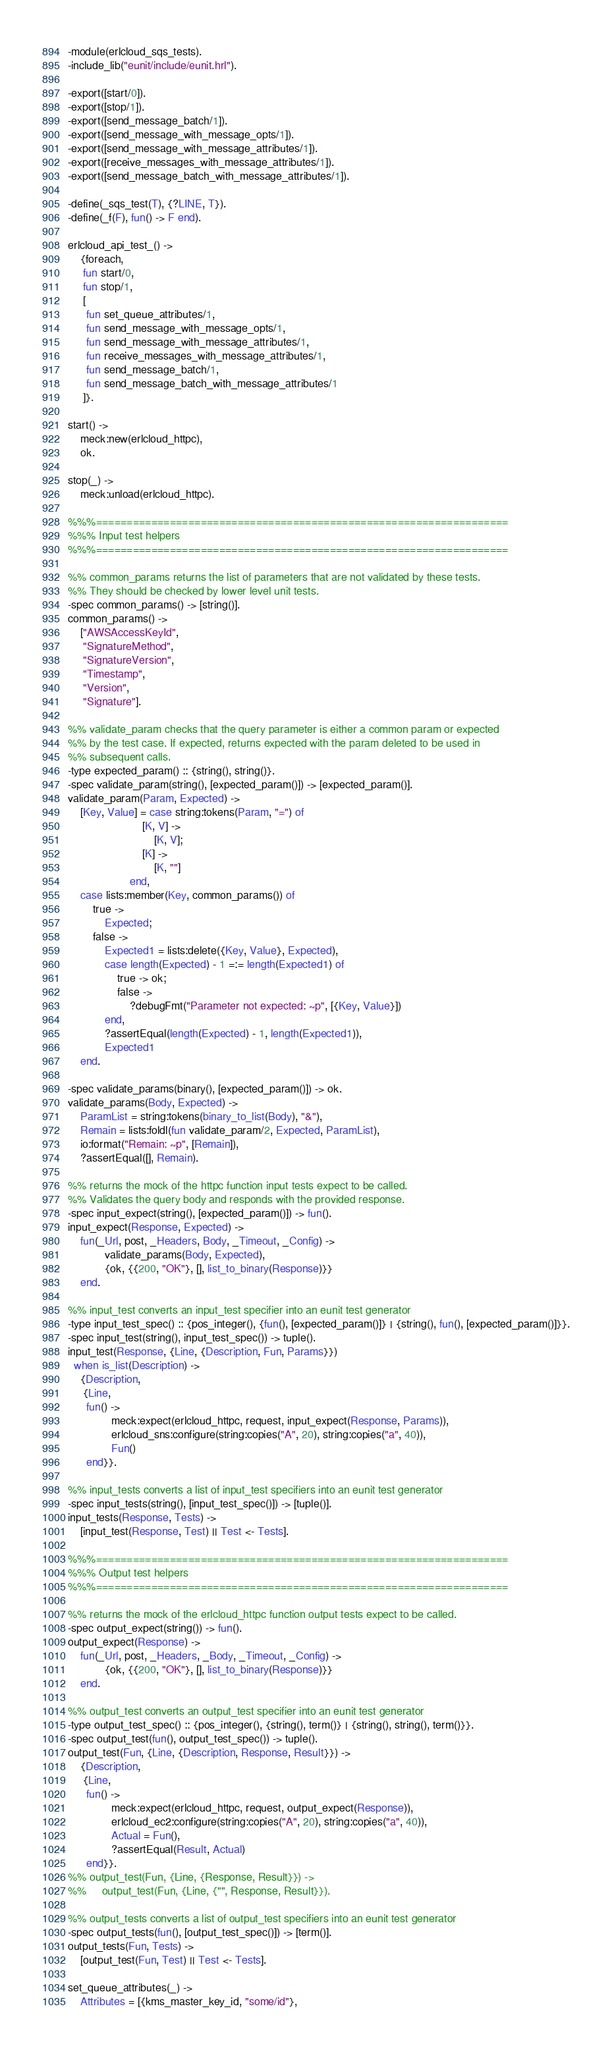<code> <loc_0><loc_0><loc_500><loc_500><_Erlang_>-module(erlcloud_sqs_tests).
-include_lib("eunit/include/eunit.hrl").

-export([start/0]).
-export([stop/1]).
-export([send_message_batch/1]).
-export([send_message_with_message_opts/1]).
-export([send_message_with_message_attributes/1]).
-export([receive_messages_with_message_attributes/1]).
-export([send_message_batch_with_message_attributes/1]).

-define(_sqs_test(T), {?LINE, T}).
-define(_f(F), fun() -> F end).

erlcloud_api_test_() ->
    {foreach,
     fun start/0,
     fun stop/1,
     [
      fun set_queue_attributes/1,
      fun send_message_with_message_opts/1,
      fun send_message_with_message_attributes/1,
      fun receive_messages_with_message_attributes/1,
      fun send_message_batch/1,
      fun send_message_batch_with_message_attributes/1
     ]}.

start() ->
    meck:new(erlcloud_httpc),
    ok.

stop(_) ->
    meck:unload(erlcloud_httpc).

%%%===================================================================
%%% Input test helpers
%%%===================================================================

%% common_params returns the list of parameters that are not validated by these tests.
%% They should be checked by lower level unit tests.
-spec common_params() -> [string()].
common_params() ->
    ["AWSAccessKeyId",
     "SignatureMethod",
     "SignatureVersion",
     "Timestamp",
     "Version",
     "Signature"].

%% validate_param checks that the query parameter is either a common param or expected
%% by the test case. If expected, returns expected with the param deleted to be used in
%% subsequent calls.
-type expected_param() :: {string(), string()}.
-spec validate_param(string(), [expected_param()]) -> [expected_param()].
validate_param(Param, Expected) ->
    [Key, Value] = case string:tokens(Param, "=") of
                        [K, V] ->
                            [K, V];
                        [K] ->
                            [K, ""]
                    end,
    case lists:member(Key, common_params()) of
        true ->
            Expected;
        false ->
            Expected1 = lists:delete({Key, Value}, Expected),
            case length(Expected) - 1 =:= length(Expected1) of
                true -> ok;
                false ->
                    ?debugFmt("Parameter not expected: ~p", [{Key, Value}])
            end,
            ?assertEqual(length(Expected) - 1, length(Expected1)),
            Expected1
    end.

-spec validate_params(binary(), [expected_param()]) -> ok.
validate_params(Body, Expected) ->
    ParamList = string:tokens(binary_to_list(Body), "&"),
    Remain = lists:foldl(fun validate_param/2, Expected, ParamList),
    io:format("Remain: ~p", [Remain]),
    ?assertEqual([], Remain).

%% returns the mock of the httpc function input tests expect to be called.
%% Validates the query body and responds with the provided response.
-spec input_expect(string(), [expected_param()]) -> fun().
input_expect(Response, Expected) ->
    fun(_Url, post, _Headers, Body, _Timeout, _Config) ->
            validate_params(Body, Expected),
            {ok, {{200, "OK"}, [], list_to_binary(Response)}}
    end.

%% input_test converts an input_test specifier into an eunit test generator
-type input_test_spec() :: {pos_integer(), {fun(), [expected_param()]} | {string(), fun(), [expected_param()]}}.
-spec input_test(string(), input_test_spec()) -> tuple().
input_test(Response, {Line, {Description, Fun, Params}})
  when is_list(Description) ->
    {Description,
     {Line,
      fun() ->
              meck:expect(erlcloud_httpc, request, input_expect(Response, Params)),
              erlcloud_sns:configure(string:copies("A", 20), string:copies("a", 40)),
              Fun()
      end}}.

%% input_tests converts a list of input_test specifiers into an eunit test generator
-spec input_tests(string(), [input_test_spec()]) -> [tuple()].
input_tests(Response, Tests) ->
    [input_test(Response, Test) || Test <- Tests].

%%%===================================================================
%%% Output test helpers
%%%===================================================================

%% returns the mock of the erlcloud_httpc function output tests expect to be called.
-spec output_expect(string()) -> fun().
output_expect(Response) ->
    fun(_Url, post, _Headers, _Body, _Timeout, _Config) ->
            {ok, {{200, "OK"}, [], list_to_binary(Response)}}
    end.

%% output_test converts an output_test specifier into an eunit test generator
-type output_test_spec() :: {pos_integer(), {string(), term()} | {string(), string(), term()}}.
-spec output_test(fun(), output_test_spec()) -> tuple().
output_test(Fun, {Line, {Description, Response, Result}}) ->
    {Description,
     {Line,
      fun() ->
              meck:expect(erlcloud_httpc, request, output_expect(Response)),
              erlcloud_ec2:configure(string:copies("A", 20), string:copies("a", 40)),
              Actual = Fun(),
              ?assertEqual(Result, Actual)
      end}}.
%% output_test(Fun, {Line, {Response, Result}}) ->
%%     output_test(Fun, {Line, {"", Response, Result}}).

%% output_tests converts a list of output_test specifiers into an eunit test generator
-spec output_tests(fun(), [output_test_spec()]) -> [term()].
output_tests(Fun, Tests) ->
    [output_test(Fun, Test) || Test <- Tests].

set_queue_attributes(_) ->
    Attributes = [{kms_master_key_id, "some/id"},</code> 